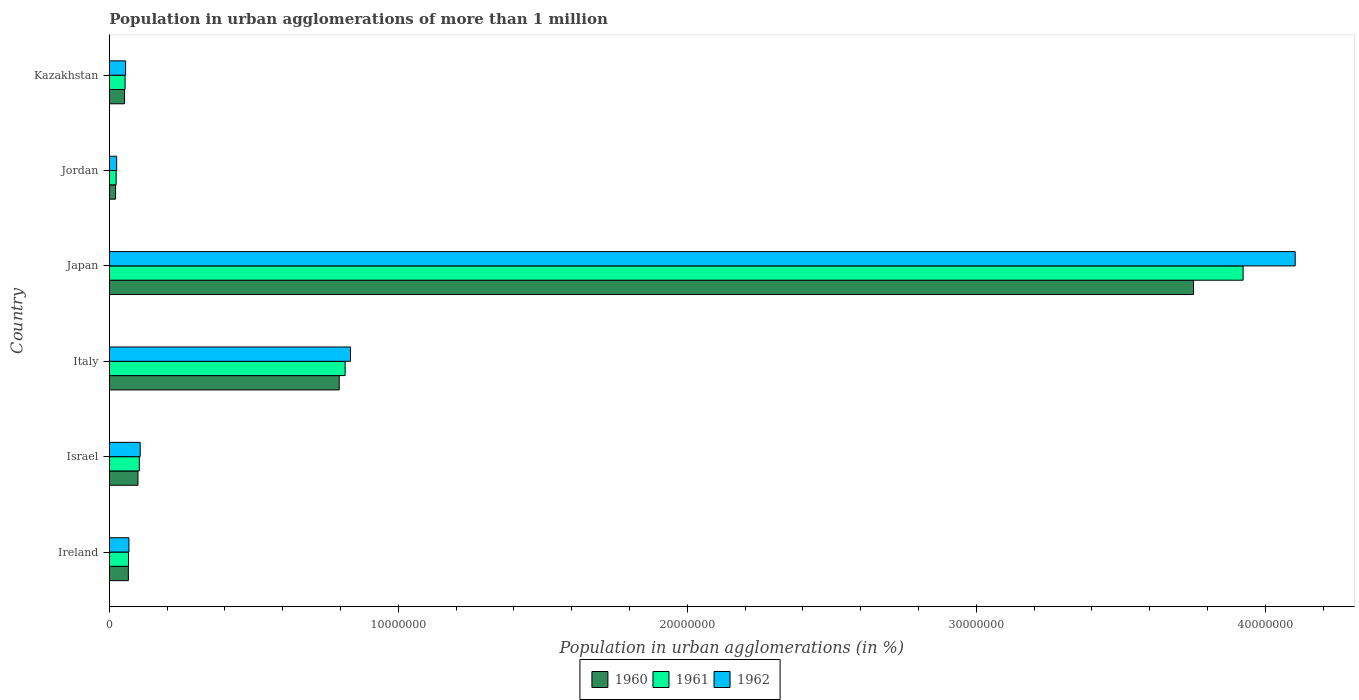How many groups of bars are there?
Ensure brevity in your answer.  6. Are the number of bars per tick equal to the number of legend labels?
Make the answer very short. Yes. What is the label of the 5th group of bars from the top?
Your answer should be very brief. Israel. In how many cases, is the number of bars for a given country not equal to the number of legend labels?
Offer a terse response. 0. What is the population in urban agglomerations in 1962 in Italy?
Make the answer very short. 8.35e+06. Across all countries, what is the maximum population in urban agglomerations in 1962?
Give a very brief answer. 4.10e+07. Across all countries, what is the minimum population in urban agglomerations in 1961?
Your answer should be very brief. 2.38e+05. In which country was the population in urban agglomerations in 1962 maximum?
Your answer should be very brief. Japan. In which country was the population in urban agglomerations in 1962 minimum?
Provide a short and direct response. Jordan. What is the total population in urban agglomerations in 1961 in the graph?
Make the answer very short. 4.99e+07. What is the difference between the population in urban agglomerations in 1962 in Japan and that in Kazakhstan?
Your answer should be very brief. 4.05e+07. What is the difference between the population in urban agglomerations in 1960 in Japan and the population in urban agglomerations in 1962 in Jordan?
Your response must be concise. 3.73e+07. What is the average population in urban agglomerations in 1962 per country?
Offer a very short reply. 8.66e+06. What is the difference between the population in urban agglomerations in 1960 and population in urban agglomerations in 1962 in Ireland?
Ensure brevity in your answer.  -1.90e+04. What is the ratio of the population in urban agglomerations in 1960 in Israel to that in Kazakhstan?
Give a very brief answer. 1.88. Is the population in urban agglomerations in 1960 in Italy less than that in Jordan?
Give a very brief answer. No. What is the difference between the highest and the second highest population in urban agglomerations in 1962?
Your response must be concise. 3.27e+07. What is the difference between the highest and the lowest population in urban agglomerations in 1961?
Offer a very short reply. 3.90e+07. Is the sum of the population in urban agglomerations in 1962 in Israel and Italy greater than the maximum population in urban agglomerations in 1961 across all countries?
Offer a terse response. No. How many countries are there in the graph?
Give a very brief answer. 6. What is the difference between two consecutive major ticks on the X-axis?
Offer a very short reply. 1.00e+07. Does the graph contain any zero values?
Your answer should be compact. No. Where does the legend appear in the graph?
Offer a terse response. Bottom center. What is the title of the graph?
Make the answer very short. Population in urban agglomerations of more than 1 million. What is the label or title of the X-axis?
Give a very brief answer. Population in urban agglomerations (in %). What is the Population in urban agglomerations (in %) in 1960 in Ireland?
Ensure brevity in your answer.  6.61e+05. What is the Population in urban agglomerations (in %) in 1961 in Ireland?
Give a very brief answer. 6.66e+05. What is the Population in urban agglomerations (in %) in 1962 in Ireland?
Offer a terse response. 6.80e+05. What is the Population in urban agglomerations (in %) of 1960 in Israel?
Your response must be concise. 9.93e+05. What is the Population in urban agglomerations (in %) of 1961 in Israel?
Provide a short and direct response. 1.04e+06. What is the Population in urban agglomerations (in %) of 1962 in Israel?
Your response must be concise. 1.07e+06. What is the Population in urban agglomerations (in %) of 1960 in Italy?
Offer a terse response. 7.96e+06. What is the Population in urban agglomerations (in %) in 1961 in Italy?
Keep it short and to the point. 8.16e+06. What is the Population in urban agglomerations (in %) of 1962 in Italy?
Offer a terse response. 8.35e+06. What is the Population in urban agglomerations (in %) in 1960 in Japan?
Your answer should be compact. 3.75e+07. What is the Population in urban agglomerations (in %) of 1961 in Japan?
Your answer should be compact. 3.92e+07. What is the Population in urban agglomerations (in %) in 1962 in Japan?
Offer a very short reply. 4.10e+07. What is the Population in urban agglomerations (in %) in 1960 in Jordan?
Offer a terse response. 2.18e+05. What is the Population in urban agglomerations (in %) in 1961 in Jordan?
Your answer should be very brief. 2.38e+05. What is the Population in urban agglomerations (in %) in 1962 in Jordan?
Keep it short and to the point. 2.55e+05. What is the Population in urban agglomerations (in %) in 1960 in Kazakhstan?
Give a very brief answer. 5.29e+05. What is the Population in urban agglomerations (in %) of 1961 in Kazakhstan?
Offer a terse response. 5.47e+05. What is the Population in urban agglomerations (in %) of 1962 in Kazakhstan?
Give a very brief answer. 5.66e+05. Across all countries, what is the maximum Population in urban agglomerations (in %) in 1960?
Make the answer very short. 3.75e+07. Across all countries, what is the maximum Population in urban agglomerations (in %) of 1961?
Offer a terse response. 3.92e+07. Across all countries, what is the maximum Population in urban agglomerations (in %) in 1962?
Keep it short and to the point. 4.10e+07. Across all countries, what is the minimum Population in urban agglomerations (in %) in 1960?
Your answer should be very brief. 2.18e+05. Across all countries, what is the minimum Population in urban agglomerations (in %) of 1961?
Your answer should be compact. 2.38e+05. Across all countries, what is the minimum Population in urban agglomerations (in %) of 1962?
Keep it short and to the point. 2.55e+05. What is the total Population in urban agglomerations (in %) in 1960 in the graph?
Offer a terse response. 4.79e+07. What is the total Population in urban agglomerations (in %) of 1961 in the graph?
Your response must be concise. 4.99e+07. What is the total Population in urban agglomerations (in %) of 1962 in the graph?
Offer a terse response. 5.20e+07. What is the difference between the Population in urban agglomerations (in %) of 1960 in Ireland and that in Israel?
Keep it short and to the point. -3.32e+05. What is the difference between the Population in urban agglomerations (in %) in 1961 in Ireland and that in Israel?
Offer a very short reply. -3.73e+05. What is the difference between the Population in urban agglomerations (in %) of 1962 in Ireland and that in Israel?
Offer a terse response. -3.90e+05. What is the difference between the Population in urban agglomerations (in %) in 1960 in Ireland and that in Italy?
Offer a terse response. -7.30e+06. What is the difference between the Population in urban agglomerations (in %) in 1961 in Ireland and that in Italy?
Keep it short and to the point. -7.50e+06. What is the difference between the Population in urban agglomerations (in %) of 1962 in Ireland and that in Italy?
Provide a succinct answer. -7.67e+06. What is the difference between the Population in urban agglomerations (in %) in 1960 in Ireland and that in Japan?
Provide a short and direct response. -3.69e+07. What is the difference between the Population in urban agglomerations (in %) of 1961 in Ireland and that in Japan?
Provide a short and direct response. -3.86e+07. What is the difference between the Population in urban agglomerations (in %) of 1962 in Ireland and that in Japan?
Your response must be concise. -4.04e+07. What is the difference between the Population in urban agglomerations (in %) in 1960 in Ireland and that in Jordan?
Your response must be concise. 4.43e+05. What is the difference between the Population in urban agglomerations (in %) of 1961 in Ireland and that in Jordan?
Make the answer very short. 4.28e+05. What is the difference between the Population in urban agglomerations (in %) in 1962 in Ireland and that in Jordan?
Your answer should be very brief. 4.25e+05. What is the difference between the Population in urban agglomerations (in %) of 1960 in Ireland and that in Kazakhstan?
Offer a very short reply. 1.33e+05. What is the difference between the Population in urban agglomerations (in %) of 1961 in Ireland and that in Kazakhstan?
Give a very brief answer. 1.20e+05. What is the difference between the Population in urban agglomerations (in %) in 1962 in Ireland and that in Kazakhstan?
Your response must be concise. 1.15e+05. What is the difference between the Population in urban agglomerations (in %) of 1960 in Israel and that in Italy?
Your answer should be compact. -6.96e+06. What is the difference between the Population in urban agglomerations (in %) of 1961 in Israel and that in Italy?
Your answer should be compact. -7.12e+06. What is the difference between the Population in urban agglomerations (in %) of 1962 in Israel and that in Italy?
Your response must be concise. -7.28e+06. What is the difference between the Population in urban agglomerations (in %) of 1960 in Israel and that in Japan?
Your response must be concise. -3.65e+07. What is the difference between the Population in urban agglomerations (in %) in 1961 in Israel and that in Japan?
Make the answer very short. -3.82e+07. What is the difference between the Population in urban agglomerations (in %) in 1962 in Israel and that in Japan?
Your response must be concise. -4.00e+07. What is the difference between the Population in urban agglomerations (in %) of 1960 in Israel and that in Jordan?
Ensure brevity in your answer.  7.75e+05. What is the difference between the Population in urban agglomerations (in %) in 1961 in Israel and that in Jordan?
Offer a terse response. 8.01e+05. What is the difference between the Population in urban agglomerations (in %) in 1962 in Israel and that in Jordan?
Provide a succinct answer. 8.15e+05. What is the difference between the Population in urban agglomerations (in %) in 1960 in Israel and that in Kazakhstan?
Make the answer very short. 4.64e+05. What is the difference between the Population in urban agglomerations (in %) in 1961 in Israel and that in Kazakhstan?
Your answer should be compact. 4.93e+05. What is the difference between the Population in urban agglomerations (in %) in 1962 in Israel and that in Kazakhstan?
Keep it short and to the point. 5.04e+05. What is the difference between the Population in urban agglomerations (in %) of 1960 in Italy and that in Japan?
Give a very brief answer. -2.96e+07. What is the difference between the Population in urban agglomerations (in %) in 1961 in Italy and that in Japan?
Ensure brevity in your answer.  -3.11e+07. What is the difference between the Population in urban agglomerations (in %) of 1962 in Italy and that in Japan?
Your answer should be very brief. -3.27e+07. What is the difference between the Population in urban agglomerations (in %) of 1960 in Italy and that in Jordan?
Keep it short and to the point. 7.74e+06. What is the difference between the Population in urban agglomerations (in %) of 1961 in Italy and that in Jordan?
Give a very brief answer. 7.92e+06. What is the difference between the Population in urban agglomerations (in %) of 1962 in Italy and that in Jordan?
Offer a terse response. 8.09e+06. What is the difference between the Population in urban agglomerations (in %) of 1960 in Italy and that in Kazakhstan?
Your answer should be very brief. 7.43e+06. What is the difference between the Population in urban agglomerations (in %) of 1961 in Italy and that in Kazakhstan?
Provide a succinct answer. 7.62e+06. What is the difference between the Population in urban agglomerations (in %) of 1962 in Italy and that in Kazakhstan?
Offer a very short reply. 7.78e+06. What is the difference between the Population in urban agglomerations (in %) of 1960 in Japan and that in Jordan?
Keep it short and to the point. 3.73e+07. What is the difference between the Population in urban agglomerations (in %) of 1961 in Japan and that in Jordan?
Your answer should be very brief. 3.90e+07. What is the difference between the Population in urban agglomerations (in %) of 1962 in Japan and that in Jordan?
Ensure brevity in your answer.  4.08e+07. What is the difference between the Population in urban agglomerations (in %) of 1960 in Japan and that in Kazakhstan?
Provide a short and direct response. 3.70e+07. What is the difference between the Population in urban agglomerations (in %) of 1961 in Japan and that in Kazakhstan?
Your answer should be compact. 3.87e+07. What is the difference between the Population in urban agglomerations (in %) of 1962 in Japan and that in Kazakhstan?
Your answer should be compact. 4.05e+07. What is the difference between the Population in urban agglomerations (in %) in 1960 in Jordan and that in Kazakhstan?
Ensure brevity in your answer.  -3.11e+05. What is the difference between the Population in urban agglomerations (in %) in 1961 in Jordan and that in Kazakhstan?
Keep it short and to the point. -3.09e+05. What is the difference between the Population in urban agglomerations (in %) in 1962 in Jordan and that in Kazakhstan?
Offer a very short reply. -3.11e+05. What is the difference between the Population in urban agglomerations (in %) in 1960 in Ireland and the Population in urban agglomerations (in %) in 1961 in Israel?
Give a very brief answer. -3.78e+05. What is the difference between the Population in urban agglomerations (in %) in 1960 in Ireland and the Population in urban agglomerations (in %) in 1962 in Israel?
Ensure brevity in your answer.  -4.09e+05. What is the difference between the Population in urban agglomerations (in %) in 1961 in Ireland and the Population in urban agglomerations (in %) in 1962 in Israel?
Provide a succinct answer. -4.04e+05. What is the difference between the Population in urban agglomerations (in %) of 1960 in Ireland and the Population in urban agglomerations (in %) of 1961 in Italy?
Your answer should be very brief. -7.50e+06. What is the difference between the Population in urban agglomerations (in %) of 1960 in Ireland and the Population in urban agglomerations (in %) of 1962 in Italy?
Provide a succinct answer. -7.69e+06. What is the difference between the Population in urban agglomerations (in %) in 1961 in Ireland and the Population in urban agglomerations (in %) in 1962 in Italy?
Provide a short and direct response. -7.68e+06. What is the difference between the Population in urban agglomerations (in %) of 1960 in Ireland and the Population in urban agglomerations (in %) of 1961 in Japan?
Offer a terse response. -3.86e+07. What is the difference between the Population in urban agglomerations (in %) of 1960 in Ireland and the Population in urban agglomerations (in %) of 1962 in Japan?
Your answer should be very brief. -4.04e+07. What is the difference between the Population in urban agglomerations (in %) in 1961 in Ireland and the Population in urban agglomerations (in %) in 1962 in Japan?
Give a very brief answer. -4.04e+07. What is the difference between the Population in urban agglomerations (in %) in 1960 in Ireland and the Population in urban agglomerations (in %) in 1961 in Jordan?
Offer a terse response. 4.23e+05. What is the difference between the Population in urban agglomerations (in %) in 1960 in Ireland and the Population in urban agglomerations (in %) in 1962 in Jordan?
Your answer should be very brief. 4.06e+05. What is the difference between the Population in urban agglomerations (in %) in 1961 in Ireland and the Population in urban agglomerations (in %) in 1962 in Jordan?
Your response must be concise. 4.12e+05. What is the difference between the Population in urban agglomerations (in %) in 1960 in Ireland and the Population in urban agglomerations (in %) in 1961 in Kazakhstan?
Offer a very short reply. 1.14e+05. What is the difference between the Population in urban agglomerations (in %) of 1960 in Ireland and the Population in urban agglomerations (in %) of 1962 in Kazakhstan?
Your answer should be compact. 9.56e+04. What is the difference between the Population in urban agglomerations (in %) of 1961 in Ireland and the Population in urban agglomerations (in %) of 1962 in Kazakhstan?
Offer a terse response. 1.01e+05. What is the difference between the Population in urban agglomerations (in %) of 1960 in Israel and the Population in urban agglomerations (in %) of 1961 in Italy?
Your answer should be very brief. -7.17e+06. What is the difference between the Population in urban agglomerations (in %) of 1960 in Israel and the Population in urban agglomerations (in %) of 1962 in Italy?
Provide a succinct answer. -7.36e+06. What is the difference between the Population in urban agglomerations (in %) in 1961 in Israel and the Population in urban agglomerations (in %) in 1962 in Italy?
Offer a very short reply. -7.31e+06. What is the difference between the Population in urban agglomerations (in %) of 1960 in Israel and the Population in urban agglomerations (in %) of 1961 in Japan?
Your response must be concise. -3.82e+07. What is the difference between the Population in urban agglomerations (in %) of 1960 in Israel and the Population in urban agglomerations (in %) of 1962 in Japan?
Provide a short and direct response. -4.00e+07. What is the difference between the Population in urban agglomerations (in %) of 1961 in Israel and the Population in urban agglomerations (in %) of 1962 in Japan?
Provide a short and direct response. -4.00e+07. What is the difference between the Population in urban agglomerations (in %) in 1960 in Israel and the Population in urban agglomerations (in %) in 1961 in Jordan?
Provide a short and direct response. 7.55e+05. What is the difference between the Population in urban agglomerations (in %) of 1960 in Israel and the Population in urban agglomerations (in %) of 1962 in Jordan?
Your response must be concise. 7.38e+05. What is the difference between the Population in urban agglomerations (in %) of 1961 in Israel and the Population in urban agglomerations (in %) of 1962 in Jordan?
Keep it short and to the point. 7.85e+05. What is the difference between the Population in urban agglomerations (in %) in 1960 in Israel and the Population in urban agglomerations (in %) in 1961 in Kazakhstan?
Give a very brief answer. 4.46e+05. What is the difference between the Population in urban agglomerations (in %) of 1960 in Israel and the Population in urban agglomerations (in %) of 1962 in Kazakhstan?
Ensure brevity in your answer.  4.27e+05. What is the difference between the Population in urban agglomerations (in %) of 1961 in Israel and the Population in urban agglomerations (in %) of 1962 in Kazakhstan?
Provide a short and direct response. 4.74e+05. What is the difference between the Population in urban agglomerations (in %) of 1960 in Italy and the Population in urban agglomerations (in %) of 1961 in Japan?
Your answer should be very brief. -3.13e+07. What is the difference between the Population in urban agglomerations (in %) in 1960 in Italy and the Population in urban agglomerations (in %) in 1962 in Japan?
Provide a succinct answer. -3.31e+07. What is the difference between the Population in urban agglomerations (in %) in 1961 in Italy and the Population in urban agglomerations (in %) in 1962 in Japan?
Your answer should be compact. -3.29e+07. What is the difference between the Population in urban agglomerations (in %) in 1960 in Italy and the Population in urban agglomerations (in %) in 1961 in Jordan?
Your answer should be very brief. 7.72e+06. What is the difference between the Population in urban agglomerations (in %) in 1960 in Italy and the Population in urban agglomerations (in %) in 1962 in Jordan?
Offer a very short reply. 7.70e+06. What is the difference between the Population in urban agglomerations (in %) of 1961 in Italy and the Population in urban agglomerations (in %) of 1962 in Jordan?
Offer a very short reply. 7.91e+06. What is the difference between the Population in urban agglomerations (in %) of 1960 in Italy and the Population in urban agglomerations (in %) of 1961 in Kazakhstan?
Make the answer very short. 7.41e+06. What is the difference between the Population in urban agglomerations (in %) in 1960 in Italy and the Population in urban agglomerations (in %) in 1962 in Kazakhstan?
Ensure brevity in your answer.  7.39e+06. What is the difference between the Population in urban agglomerations (in %) of 1961 in Italy and the Population in urban agglomerations (in %) of 1962 in Kazakhstan?
Your answer should be very brief. 7.60e+06. What is the difference between the Population in urban agglomerations (in %) of 1960 in Japan and the Population in urban agglomerations (in %) of 1961 in Jordan?
Ensure brevity in your answer.  3.73e+07. What is the difference between the Population in urban agglomerations (in %) in 1960 in Japan and the Population in urban agglomerations (in %) in 1962 in Jordan?
Offer a very short reply. 3.73e+07. What is the difference between the Population in urban agglomerations (in %) in 1961 in Japan and the Population in urban agglomerations (in %) in 1962 in Jordan?
Your answer should be very brief. 3.90e+07. What is the difference between the Population in urban agglomerations (in %) of 1960 in Japan and the Population in urban agglomerations (in %) of 1961 in Kazakhstan?
Ensure brevity in your answer.  3.70e+07. What is the difference between the Population in urban agglomerations (in %) of 1960 in Japan and the Population in urban agglomerations (in %) of 1962 in Kazakhstan?
Provide a short and direct response. 3.70e+07. What is the difference between the Population in urban agglomerations (in %) in 1961 in Japan and the Population in urban agglomerations (in %) in 1962 in Kazakhstan?
Ensure brevity in your answer.  3.87e+07. What is the difference between the Population in urban agglomerations (in %) in 1960 in Jordan and the Population in urban agglomerations (in %) in 1961 in Kazakhstan?
Provide a succinct answer. -3.29e+05. What is the difference between the Population in urban agglomerations (in %) in 1960 in Jordan and the Population in urban agglomerations (in %) in 1962 in Kazakhstan?
Offer a very short reply. -3.48e+05. What is the difference between the Population in urban agglomerations (in %) of 1961 in Jordan and the Population in urban agglomerations (in %) of 1962 in Kazakhstan?
Your response must be concise. -3.27e+05. What is the average Population in urban agglomerations (in %) in 1960 per country?
Ensure brevity in your answer.  7.98e+06. What is the average Population in urban agglomerations (in %) in 1961 per country?
Offer a terse response. 8.31e+06. What is the average Population in urban agglomerations (in %) of 1962 per country?
Provide a short and direct response. 8.66e+06. What is the difference between the Population in urban agglomerations (in %) in 1960 and Population in urban agglomerations (in %) in 1961 in Ireland?
Provide a succinct answer. -5272. What is the difference between the Population in urban agglomerations (in %) in 1960 and Population in urban agglomerations (in %) in 1962 in Ireland?
Offer a terse response. -1.90e+04. What is the difference between the Population in urban agglomerations (in %) of 1961 and Population in urban agglomerations (in %) of 1962 in Ireland?
Give a very brief answer. -1.37e+04. What is the difference between the Population in urban agglomerations (in %) in 1960 and Population in urban agglomerations (in %) in 1961 in Israel?
Keep it short and to the point. -4.66e+04. What is the difference between the Population in urban agglomerations (in %) in 1960 and Population in urban agglomerations (in %) in 1962 in Israel?
Make the answer very short. -7.73e+04. What is the difference between the Population in urban agglomerations (in %) in 1961 and Population in urban agglomerations (in %) in 1962 in Israel?
Provide a short and direct response. -3.06e+04. What is the difference between the Population in urban agglomerations (in %) in 1960 and Population in urban agglomerations (in %) in 1961 in Italy?
Offer a terse response. -2.05e+05. What is the difference between the Population in urban agglomerations (in %) in 1960 and Population in urban agglomerations (in %) in 1962 in Italy?
Provide a succinct answer. -3.91e+05. What is the difference between the Population in urban agglomerations (in %) of 1961 and Population in urban agglomerations (in %) of 1962 in Italy?
Offer a terse response. -1.86e+05. What is the difference between the Population in urban agglomerations (in %) in 1960 and Population in urban agglomerations (in %) in 1961 in Japan?
Provide a succinct answer. -1.72e+06. What is the difference between the Population in urban agglomerations (in %) of 1960 and Population in urban agglomerations (in %) of 1962 in Japan?
Your response must be concise. -3.52e+06. What is the difference between the Population in urban agglomerations (in %) in 1961 and Population in urban agglomerations (in %) in 1962 in Japan?
Ensure brevity in your answer.  -1.80e+06. What is the difference between the Population in urban agglomerations (in %) in 1960 and Population in urban agglomerations (in %) in 1961 in Jordan?
Your answer should be very brief. -2.01e+04. What is the difference between the Population in urban agglomerations (in %) in 1960 and Population in urban agglomerations (in %) in 1962 in Jordan?
Your answer should be very brief. -3.67e+04. What is the difference between the Population in urban agglomerations (in %) in 1961 and Population in urban agglomerations (in %) in 1962 in Jordan?
Offer a terse response. -1.65e+04. What is the difference between the Population in urban agglomerations (in %) in 1960 and Population in urban agglomerations (in %) in 1961 in Kazakhstan?
Provide a succinct answer. -1.82e+04. What is the difference between the Population in urban agglomerations (in %) of 1960 and Population in urban agglomerations (in %) of 1962 in Kazakhstan?
Keep it short and to the point. -3.70e+04. What is the difference between the Population in urban agglomerations (in %) in 1961 and Population in urban agglomerations (in %) in 1962 in Kazakhstan?
Your answer should be very brief. -1.88e+04. What is the ratio of the Population in urban agglomerations (in %) in 1960 in Ireland to that in Israel?
Keep it short and to the point. 0.67. What is the ratio of the Population in urban agglomerations (in %) of 1961 in Ireland to that in Israel?
Provide a succinct answer. 0.64. What is the ratio of the Population in urban agglomerations (in %) of 1962 in Ireland to that in Israel?
Your answer should be very brief. 0.64. What is the ratio of the Population in urban agglomerations (in %) in 1960 in Ireland to that in Italy?
Offer a very short reply. 0.08. What is the ratio of the Population in urban agglomerations (in %) of 1961 in Ireland to that in Italy?
Provide a short and direct response. 0.08. What is the ratio of the Population in urban agglomerations (in %) in 1962 in Ireland to that in Italy?
Make the answer very short. 0.08. What is the ratio of the Population in urban agglomerations (in %) in 1960 in Ireland to that in Japan?
Offer a terse response. 0.02. What is the ratio of the Population in urban agglomerations (in %) in 1961 in Ireland to that in Japan?
Your answer should be very brief. 0.02. What is the ratio of the Population in urban agglomerations (in %) in 1962 in Ireland to that in Japan?
Keep it short and to the point. 0.02. What is the ratio of the Population in urban agglomerations (in %) in 1960 in Ireland to that in Jordan?
Provide a short and direct response. 3.03. What is the ratio of the Population in urban agglomerations (in %) of 1961 in Ireland to that in Jordan?
Offer a very short reply. 2.8. What is the ratio of the Population in urban agglomerations (in %) in 1962 in Ireland to that in Jordan?
Keep it short and to the point. 2.67. What is the ratio of the Population in urban agglomerations (in %) in 1960 in Ireland to that in Kazakhstan?
Offer a very short reply. 1.25. What is the ratio of the Population in urban agglomerations (in %) in 1961 in Ireland to that in Kazakhstan?
Your answer should be compact. 1.22. What is the ratio of the Population in urban agglomerations (in %) in 1962 in Ireland to that in Kazakhstan?
Keep it short and to the point. 1.2. What is the ratio of the Population in urban agglomerations (in %) in 1960 in Israel to that in Italy?
Your response must be concise. 0.12. What is the ratio of the Population in urban agglomerations (in %) of 1961 in Israel to that in Italy?
Offer a very short reply. 0.13. What is the ratio of the Population in urban agglomerations (in %) in 1962 in Israel to that in Italy?
Keep it short and to the point. 0.13. What is the ratio of the Population in urban agglomerations (in %) of 1960 in Israel to that in Japan?
Your answer should be compact. 0.03. What is the ratio of the Population in urban agglomerations (in %) of 1961 in Israel to that in Japan?
Make the answer very short. 0.03. What is the ratio of the Population in urban agglomerations (in %) in 1962 in Israel to that in Japan?
Your answer should be very brief. 0.03. What is the ratio of the Population in urban agglomerations (in %) of 1960 in Israel to that in Jordan?
Your answer should be compact. 4.55. What is the ratio of the Population in urban agglomerations (in %) of 1961 in Israel to that in Jordan?
Give a very brief answer. 4.36. What is the ratio of the Population in urban agglomerations (in %) of 1962 in Israel to that in Jordan?
Keep it short and to the point. 4.2. What is the ratio of the Population in urban agglomerations (in %) of 1960 in Israel to that in Kazakhstan?
Provide a short and direct response. 1.88. What is the ratio of the Population in urban agglomerations (in %) of 1961 in Israel to that in Kazakhstan?
Provide a succinct answer. 1.9. What is the ratio of the Population in urban agglomerations (in %) in 1962 in Israel to that in Kazakhstan?
Offer a very short reply. 1.89. What is the ratio of the Population in urban agglomerations (in %) in 1960 in Italy to that in Japan?
Offer a terse response. 0.21. What is the ratio of the Population in urban agglomerations (in %) in 1961 in Italy to that in Japan?
Make the answer very short. 0.21. What is the ratio of the Population in urban agglomerations (in %) of 1962 in Italy to that in Japan?
Ensure brevity in your answer.  0.2. What is the ratio of the Population in urban agglomerations (in %) in 1960 in Italy to that in Jordan?
Make the answer very short. 36.48. What is the ratio of the Population in urban agglomerations (in %) of 1961 in Italy to that in Jordan?
Offer a very short reply. 34.26. What is the ratio of the Population in urban agglomerations (in %) of 1962 in Italy to that in Jordan?
Your response must be concise. 32.77. What is the ratio of the Population in urban agglomerations (in %) in 1960 in Italy to that in Kazakhstan?
Provide a short and direct response. 15.05. What is the ratio of the Population in urban agglomerations (in %) in 1961 in Italy to that in Kazakhstan?
Give a very brief answer. 14.93. What is the ratio of the Population in urban agglomerations (in %) in 1962 in Italy to that in Kazakhstan?
Provide a short and direct response. 14.76. What is the ratio of the Population in urban agglomerations (in %) in 1960 in Japan to that in Jordan?
Your answer should be very brief. 172.02. What is the ratio of the Population in urban agglomerations (in %) of 1961 in Japan to that in Jordan?
Offer a very short reply. 164.68. What is the ratio of the Population in urban agglomerations (in %) of 1962 in Japan to that in Jordan?
Offer a very short reply. 161.08. What is the ratio of the Population in urban agglomerations (in %) in 1960 in Japan to that in Kazakhstan?
Your answer should be compact. 70.97. What is the ratio of the Population in urban agglomerations (in %) of 1961 in Japan to that in Kazakhstan?
Offer a very short reply. 71.75. What is the ratio of the Population in urban agglomerations (in %) in 1962 in Japan to that in Kazakhstan?
Offer a very short reply. 72.55. What is the ratio of the Population in urban agglomerations (in %) of 1960 in Jordan to that in Kazakhstan?
Offer a terse response. 0.41. What is the ratio of the Population in urban agglomerations (in %) of 1961 in Jordan to that in Kazakhstan?
Provide a short and direct response. 0.44. What is the ratio of the Population in urban agglomerations (in %) in 1962 in Jordan to that in Kazakhstan?
Keep it short and to the point. 0.45. What is the difference between the highest and the second highest Population in urban agglomerations (in %) in 1960?
Offer a very short reply. 2.96e+07. What is the difference between the highest and the second highest Population in urban agglomerations (in %) of 1961?
Give a very brief answer. 3.11e+07. What is the difference between the highest and the second highest Population in urban agglomerations (in %) in 1962?
Ensure brevity in your answer.  3.27e+07. What is the difference between the highest and the lowest Population in urban agglomerations (in %) of 1960?
Make the answer very short. 3.73e+07. What is the difference between the highest and the lowest Population in urban agglomerations (in %) in 1961?
Your response must be concise. 3.90e+07. What is the difference between the highest and the lowest Population in urban agglomerations (in %) in 1962?
Offer a terse response. 4.08e+07. 